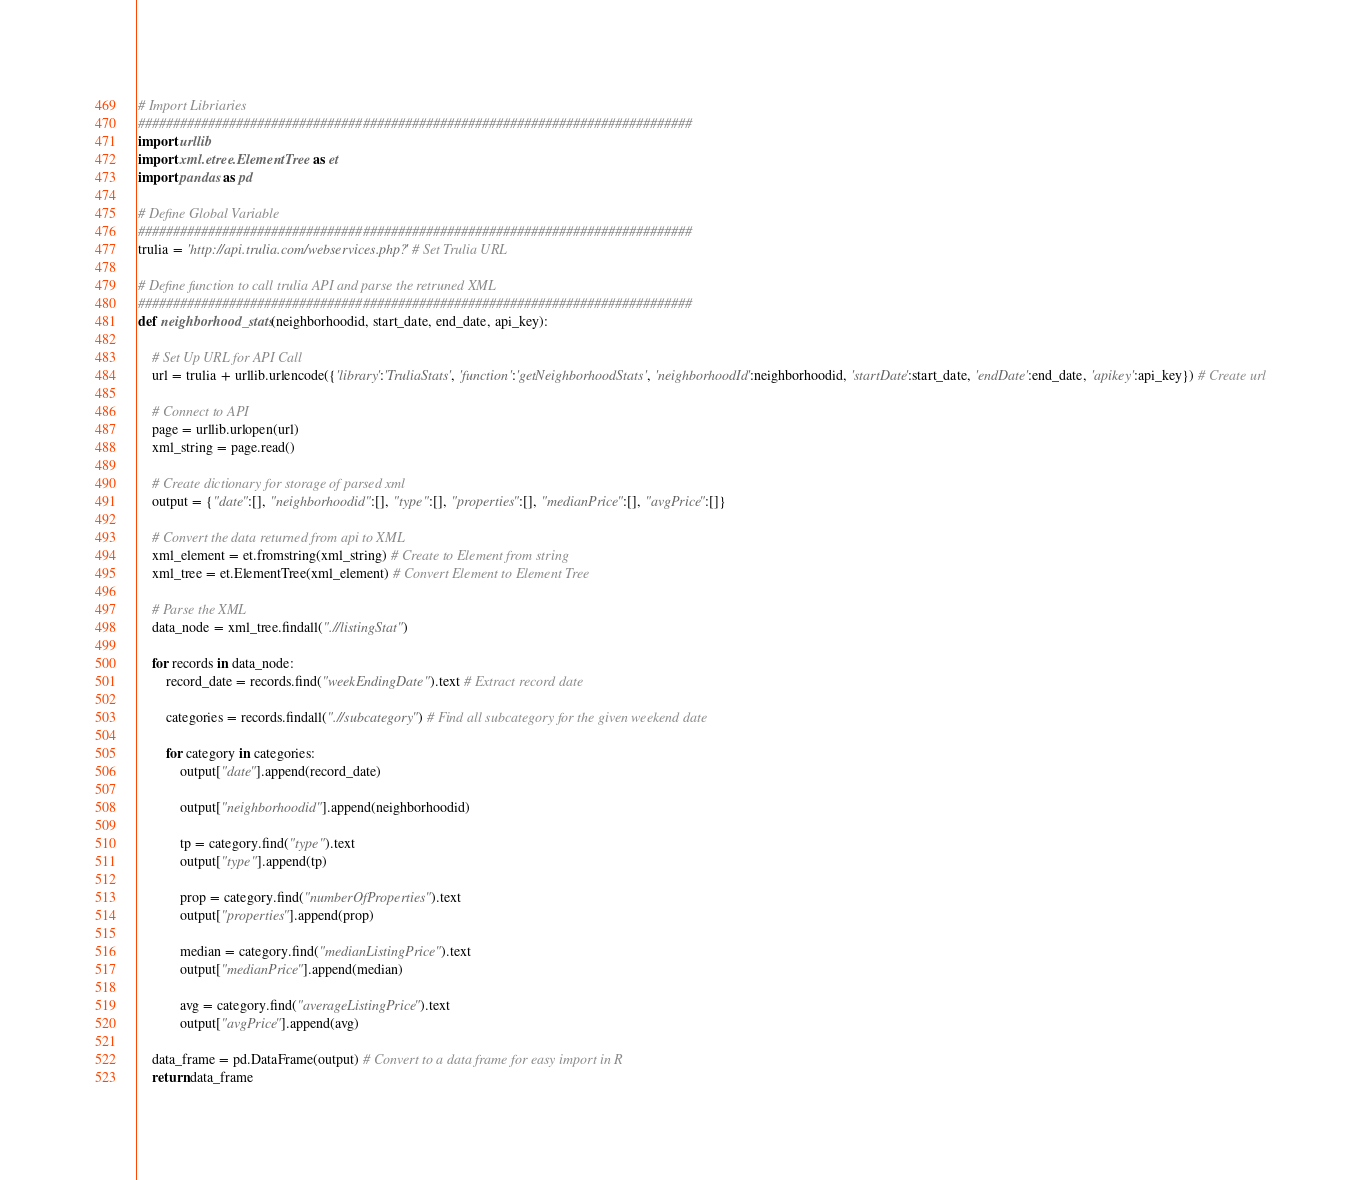Convert code to text. <code><loc_0><loc_0><loc_500><loc_500><_Python_># Import Libriaries
###############################################################################
import urllib
import xml.etree.ElementTree as et
import pandas as pd

# Define Global Variable
###############################################################################
trulia = 'http://api.trulia.com/webservices.php?' # Set Trulia URL

# Define function to call trulia API and parse the retruned XML
###############################################################################
def neighborhood_stats(neighborhoodid, start_date, end_date, api_key):

	# Set Up URL for API Call
	url = trulia + urllib.urlencode({'library':'TruliaStats', 'function':'getNeighborhoodStats', 'neighborhoodId':neighborhoodid, 'startDate':start_date, 'endDate':end_date, 'apikey':api_key}) # Create url

	# Connect to API
	page = urllib.urlopen(url) 
	xml_string = page.read()

	# Create dictionary for storage of parsed xml
	output = {"date":[], "neighborhoodid":[], "type":[], "properties":[], "medianPrice":[], "avgPrice":[]}

	# Convert the data returned from api to XML
	xml_element = et.fromstring(xml_string) # Create to Element from string
	xml_tree = et.ElementTree(xml_element) # Convert Element to Element Tree

	# Parse the XML
	data_node = xml_tree.findall(".//listingStat")

	for records in data_node:
		record_date = records.find("weekEndingDate").text # Extract record date
			
		categories = records.findall(".//subcategory") # Find all subcategory for the given weekend date
    
		for category in categories:
			output["date"].append(record_date) 

			output["neighborhoodid"].append(neighborhoodid)

			tp = category.find("type").text
			output["type"].append(tp)

			prop = category.find("numberOfProperties").text
			output["properties"].append(prop)

			median = category.find("medianListingPrice").text
			output["medianPrice"].append(median)
        
			avg = category.find("averageListingPrice").text
			output["avgPrice"].append(avg)

	data_frame = pd.DataFrame(output) # Convert to a data frame for easy import in R
	return data_frame</code> 